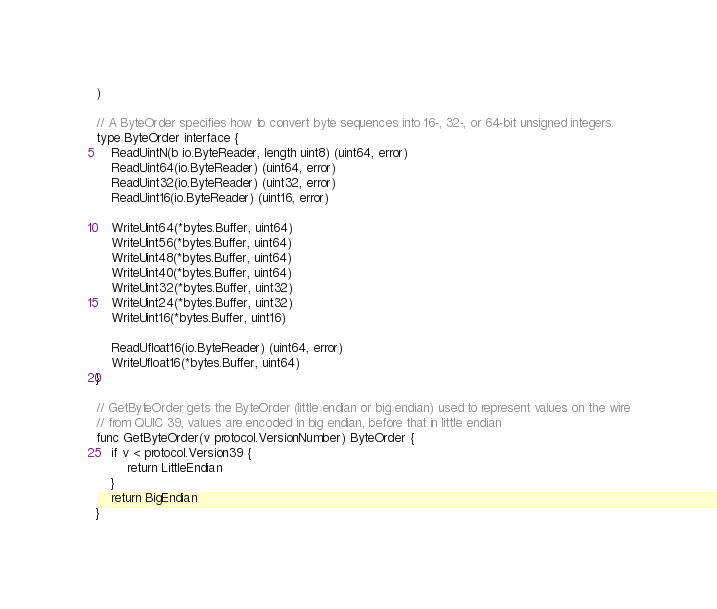<code> <loc_0><loc_0><loc_500><loc_500><_Go_>)

// A ByteOrder specifies how to convert byte sequences into 16-, 32-, or 64-bit unsigned integers.
type ByteOrder interface {
	ReadUintN(b io.ByteReader, length uint8) (uint64, error)
	ReadUint64(io.ByteReader) (uint64, error)
	ReadUint32(io.ByteReader) (uint32, error)
	ReadUint16(io.ByteReader) (uint16, error)

	WriteUint64(*bytes.Buffer, uint64)
	WriteUint56(*bytes.Buffer, uint64)
	WriteUint48(*bytes.Buffer, uint64)
	WriteUint40(*bytes.Buffer, uint64)
	WriteUint32(*bytes.Buffer, uint32)
	WriteUint24(*bytes.Buffer, uint32)
	WriteUint16(*bytes.Buffer, uint16)

	ReadUfloat16(io.ByteReader) (uint64, error)
	WriteUfloat16(*bytes.Buffer, uint64)
}

// GetByteOrder gets the ByteOrder (little endian or big endian) used to represent values on the wire
// from QUIC 39, values are encoded in big endian, before that in little endian
func GetByteOrder(v protocol.VersionNumber) ByteOrder {
	if v < protocol.Version39 {
		return LittleEndian
	}
	return BigEndian
}
</code> 